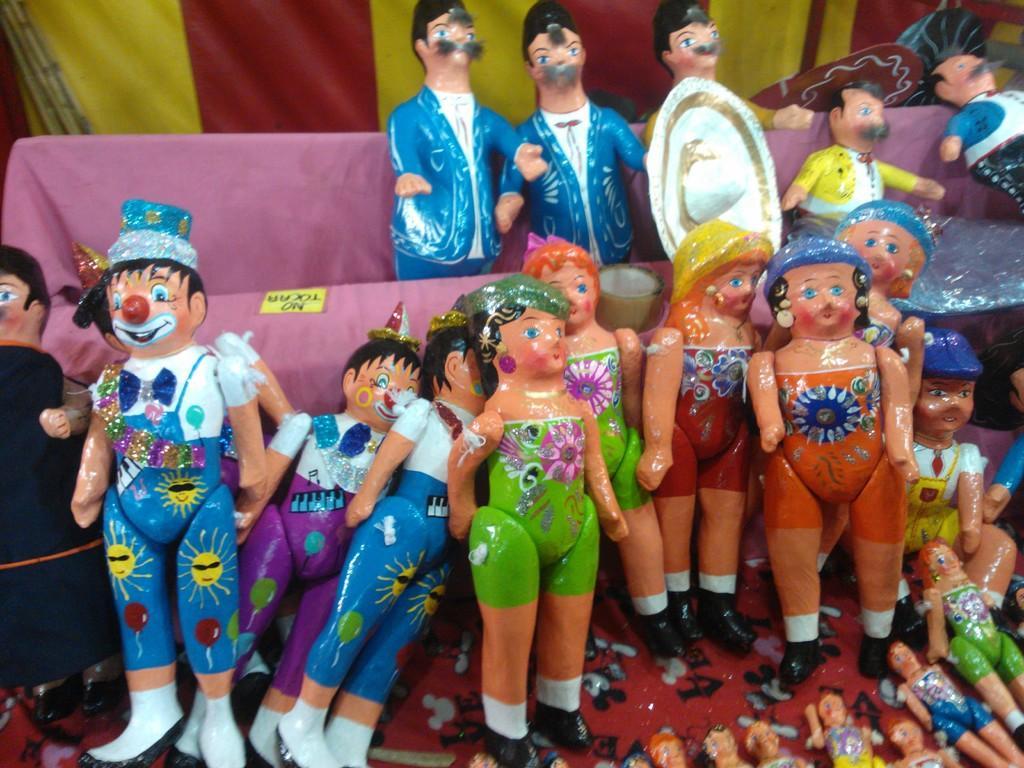Could you give a brief overview of what you see in this image? In this image I can see some toys among them some are in a box. 